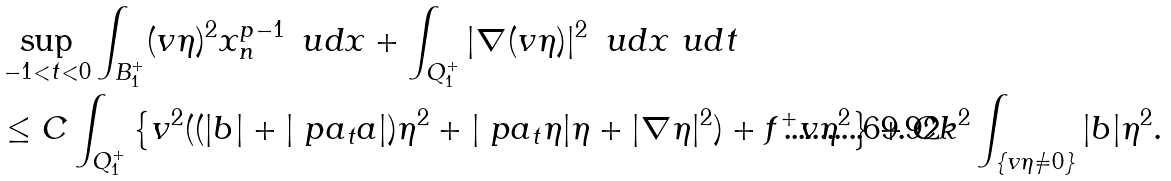Convert formula to latex. <formula><loc_0><loc_0><loc_500><loc_500>& \sup _ { - 1 < t < 0 } \int _ { B _ { 1 } ^ { + } } ( v \eta ) ^ { 2 } x _ { n } ^ { p - 1 } \, \ u d x + \int _ { Q _ { 1 } ^ { + } } | \nabla ( v \eta ) | ^ { 2 } \, \ u d x \ u d t \\ & \leq C \int _ { Q _ { 1 } ^ { + } } \left \{ v ^ { 2 } ( ( | b | + | \ p a _ { t } a | ) \eta ^ { 2 } + | \ p a _ { t } \eta | \eta + | \nabla \eta | ^ { 2 } ) + f ^ { + } v \eta ^ { 2 } \right \} + C k ^ { 2 } \int _ { \{ v \eta \neq 0 \} } | b | \eta ^ { 2 } .</formula> 